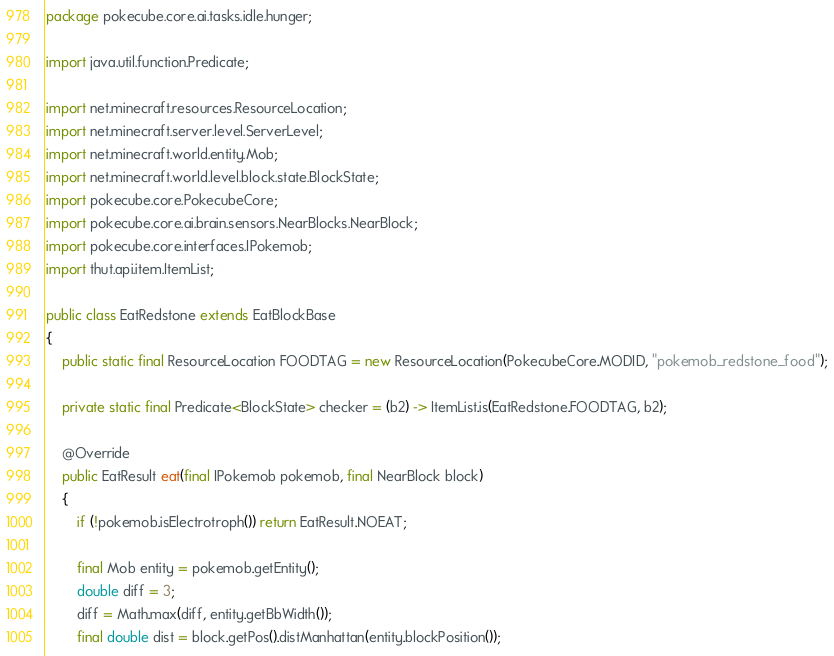<code> <loc_0><loc_0><loc_500><loc_500><_Java_>package pokecube.core.ai.tasks.idle.hunger;

import java.util.function.Predicate;

import net.minecraft.resources.ResourceLocation;
import net.minecraft.server.level.ServerLevel;
import net.minecraft.world.entity.Mob;
import net.minecraft.world.level.block.state.BlockState;
import pokecube.core.PokecubeCore;
import pokecube.core.ai.brain.sensors.NearBlocks.NearBlock;
import pokecube.core.interfaces.IPokemob;
import thut.api.item.ItemList;

public class EatRedstone extends EatBlockBase
{
    public static final ResourceLocation FOODTAG = new ResourceLocation(PokecubeCore.MODID, "pokemob_redstone_food");

    private static final Predicate<BlockState> checker = (b2) -> ItemList.is(EatRedstone.FOODTAG, b2);

    @Override
    public EatResult eat(final IPokemob pokemob, final NearBlock block)
    {
        if (!pokemob.isElectrotroph()) return EatResult.NOEAT;

        final Mob entity = pokemob.getEntity();
        double diff = 3;
        diff = Math.max(diff, entity.getBbWidth());
        final double dist = block.getPos().distManhattan(entity.blockPosition());</code> 